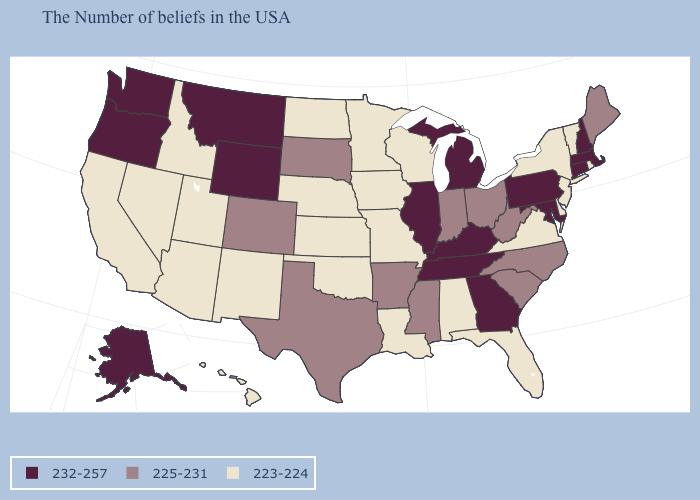What is the highest value in the MidWest ?
Short answer required. 232-257. What is the value of Missouri?
Be succinct. 223-224. Which states have the lowest value in the USA?
Keep it brief. Rhode Island, Vermont, New York, New Jersey, Delaware, Virginia, Florida, Alabama, Wisconsin, Louisiana, Missouri, Minnesota, Iowa, Kansas, Nebraska, Oklahoma, North Dakota, New Mexico, Utah, Arizona, Idaho, Nevada, California, Hawaii. What is the value of North Dakota?
Concise answer only. 223-224. What is the value of South Dakota?
Be succinct. 225-231. What is the lowest value in the USA?
Keep it brief. 223-224. Does Alaska have the highest value in the USA?
Short answer required. Yes. What is the value of South Dakota?
Answer briefly. 225-231. Does South Carolina have a higher value than Nevada?
Be succinct. Yes. What is the highest value in the MidWest ?
Answer briefly. 232-257. What is the highest value in the Northeast ?
Write a very short answer. 232-257. Name the states that have a value in the range 232-257?
Write a very short answer. Massachusetts, New Hampshire, Connecticut, Maryland, Pennsylvania, Georgia, Michigan, Kentucky, Tennessee, Illinois, Wyoming, Montana, Washington, Oregon, Alaska. What is the value of Illinois?
Answer briefly. 232-257. Name the states that have a value in the range 223-224?
Concise answer only. Rhode Island, Vermont, New York, New Jersey, Delaware, Virginia, Florida, Alabama, Wisconsin, Louisiana, Missouri, Minnesota, Iowa, Kansas, Nebraska, Oklahoma, North Dakota, New Mexico, Utah, Arizona, Idaho, Nevada, California, Hawaii. Among the states that border New Jersey , does Pennsylvania have the highest value?
Concise answer only. Yes. 